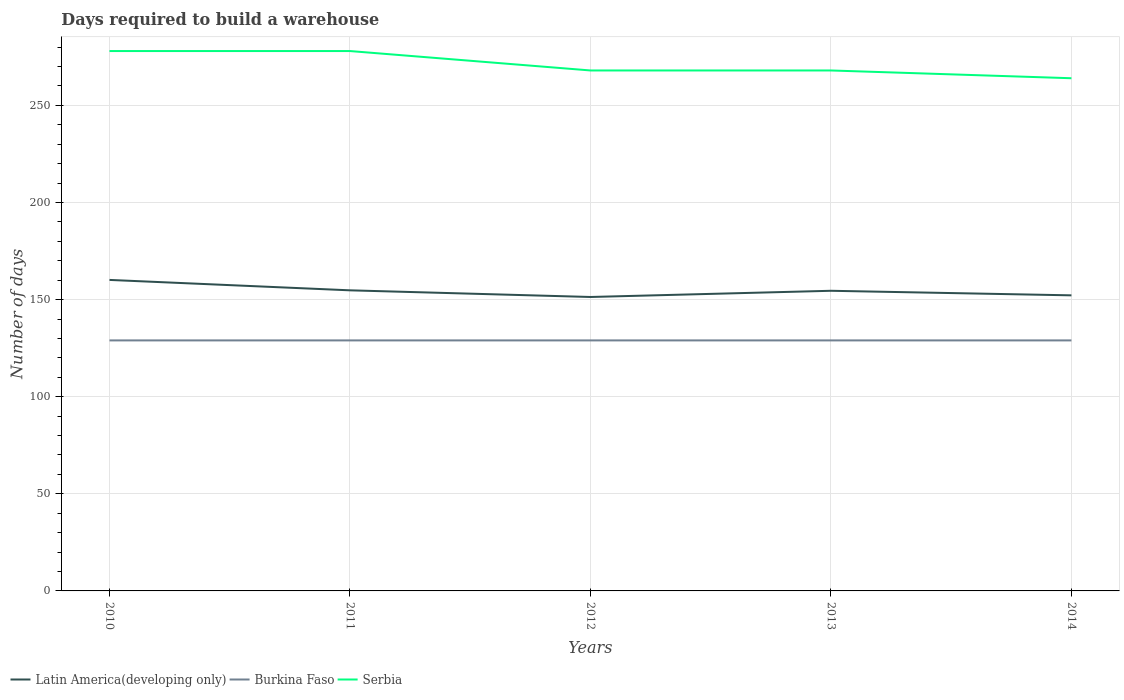How many different coloured lines are there?
Your response must be concise. 3. Does the line corresponding to Burkina Faso intersect with the line corresponding to Serbia?
Make the answer very short. No. Is the number of lines equal to the number of legend labels?
Your answer should be compact. Yes. Across all years, what is the maximum days required to build a warehouse in in Serbia?
Keep it short and to the point. 264. In which year was the days required to build a warehouse in in Serbia maximum?
Your answer should be very brief. 2014. What is the total days required to build a warehouse in in Latin America(developing only) in the graph?
Provide a short and direct response. 3.43. What is the difference between the highest and the second highest days required to build a warehouse in in Latin America(developing only)?
Offer a terse response. 8.79. What is the difference between the highest and the lowest days required to build a warehouse in in Burkina Faso?
Give a very brief answer. 0. Is the days required to build a warehouse in in Latin America(developing only) strictly greater than the days required to build a warehouse in in Serbia over the years?
Keep it short and to the point. Yes. How many years are there in the graph?
Keep it short and to the point. 5. What is the difference between two consecutive major ticks on the Y-axis?
Make the answer very short. 50. Are the values on the major ticks of Y-axis written in scientific E-notation?
Your response must be concise. No. Where does the legend appear in the graph?
Offer a terse response. Bottom left. How are the legend labels stacked?
Provide a short and direct response. Horizontal. What is the title of the graph?
Your answer should be compact. Days required to build a warehouse. Does "Bahrain" appear as one of the legend labels in the graph?
Your response must be concise. No. What is the label or title of the X-axis?
Make the answer very short. Years. What is the label or title of the Y-axis?
Ensure brevity in your answer.  Number of days. What is the Number of days of Latin America(developing only) in 2010?
Your response must be concise. 160.14. What is the Number of days in Burkina Faso in 2010?
Provide a short and direct response. 129. What is the Number of days in Serbia in 2010?
Make the answer very short. 278. What is the Number of days of Latin America(developing only) in 2011?
Provide a short and direct response. 154.79. What is the Number of days of Burkina Faso in 2011?
Give a very brief answer. 129. What is the Number of days of Serbia in 2011?
Keep it short and to the point. 278. What is the Number of days of Latin America(developing only) in 2012?
Your response must be concise. 151.36. What is the Number of days of Burkina Faso in 2012?
Keep it short and to the point. 129. What is the Number of days in Serbia in 2012?
Give a very brief answer. 268. What is the Number of days of Latin America(developing only) in 2013?
Make the answer very short. 154.55. What is the Number of days in Burkina Faso in 2013?
Your answer should be compact. 129. What is the Number of days of Serbia in 2013?
Give a very brief answer. 268. What is the Number of days in Latin America(developing only) in 2014?
Your answer should be very brief. 152.2. What is the Number of days of Burkina Faso in 2014?
Your answer should be compact. 129. What is the Number of days in Serbia in 2014?
Your answer should be very brief. 264. Across all years, what is the maximum Number of days of Latin America(developing only)?
Make the answer very short. 160.14. Across all years, what is the maximum Number of days in Burkina Faso?
Make the answer very short. 129. Across all years, what is the maximum Number of days of Serbia?
Provide a short and direct response. 278. Across all years, what is the minimum Number of days of Latin America(developing only)?
Your answer should be very brief. 151.36. Across all years, what is the minimum Number of days of Burkina Faso?
Your answer should be very brief. 129. Across all years, what is the minimum Number of days in Serbia?
Give a very brief answer. 264. What is the total Number of days of Latin America(developing only) in the graph?
Your answer should be compact. 773.03. What is the total Number of days in Burkina Faso in the graph?
Provide a succinct answer. 645. What is the total Number of days in Serbia in the graph?
Provide a succinct answer. 1356. What is the difference between the Number of days of Latin America(developing only) in 2010 and that in 2011?
Your response must be concise. 5.36. What is the difference between the Number of days of Burkina Faso in 2010 and that in 2011?
Offer a terse response. 0. What is the difference between the Number of days of Serbia in 2010 and that in 2011?
Make the answer very short. 0. What is the difference between the Number of days in Latin America(developing only) in 2010 and that in 2012?
Provide a short and direct response. 8.79. What is the difference between the Number of days in Burkina Faso in 2010 and that in 2012?
Provide a short and direct response. 0. What is the difference between the Number of days of Latin America(developing only) in 2010 and that in 2013?
Provide a succinct answer. 5.59. What is the difference between the Number of days in Serbia in 2010 and that in 2013?
Make the answer very short. 10. What is the difference between the Number of days in Latin America(developing only) in 2010 and that in 2014?
Offer a terse response. 7.94. What is the difference between the Number of days of Latin America(developing only) in 2011 and that in 2012?
Provide a short and direct response. 3.43. What is the difference between the Number of days in Serbia in 2011 and that in 2012?
Your answer should be very brief. 10. What is the difference between the Number of days in Latin America(developing only) in 2011 and that in 2013?
Ensure brevity in your answer.  0.24. What is the difference between the Number of days of Serbia in 2011 and that in 2013?
Your answer should be very brief. 10. What is the difference between the Number of days of Latin America(developing only) in 2011 and that in 2014?
Your answer should be compact. 2.59. What is the difference between the Number of days of Serbia in 2011 and that in 2014?
Make the answer very short. 14. What is the difference between the Number of days in Latin America(developing only) in 2012 and that in 2013?
Provide a short and direct response. -3.19. What is the difference between the Number of days of Latin America(developing only) in 2012 and that in 2014?
Ensure brevity in your answer.  -0.84. What is the difference between the Number of days in Burkina Faso in 2012 and that in 2014?
Provide a succinct answer. 0. What is the difference between the Number of days in Latin America(developing only) in 2013 and that in 2014?
Your answer should be compact. 2.35. What is the difference between the Number of days of Latin America(developing only) in 2010 and the Number of days of Burkina Faso in 2011?
Offer a very short reply. 31.14. What is the difference between the Number of days in Latin America(developing only) in 2010 and the Number of days in Serbia in 2011?
Keep it short and to the point. -117.86. What is the difference between the Number of days of Burkina Faso in 2010 and the Number of days of Serbia in 2011?
Offer a terse response. -149. What is the difference between the Number of days of Latin America(developing only) in 2010 and the Number of days of Burkina Faso in 2012?
Your response must be concise. 31.14. What is the difference between the Number of days in Latin America(developing only) in 2010 and the Number of days in Serbia in 2012?
Make the answer very short. -107.86. What is the difference between the Number of days of Burkina Faso in 2010 and the Number of days of Serbia in 2012?
Your answer should be very brief. -139. What is the difference between the Number of days in Latin America(developing only) in 2010 and the Number of days in Burkina Faso in 2013?
Provide a succinct answer. 31.14. What is the difference between the Number of days of Latin America(developing only) in 2010 and the Number of days of Serbia in 2013?
Your answer should be very brief. -107.86. What is the difference between the Number of days in Burkina Faso in 2010 and the Number of days in Serbia in 2013?
Provide a short and direct response. -139. What is the difference between the Number of days of Latin America(developing only) in 2010 and the Number of days of Burkina Faso in 2014?
Keep it short and to the point. 31.14. What is the difference between the Number of days of Latin America(developing only) in 2010 and the Number of days of Serbia in 2014?
Give a very brief answer. -103.86. What is the difference between the Number of days of Burkina Faso in 2010 and the Number of days of Serbia in 2014?
Make the answer very short. -135. What is the difference between the Number of days in Latin America(developing only) in 2011 and the Number of days in Burkina Faso in 2012?
Make the answer very short. 25.79. What is the difference between the Number of days in Latin America(developing only) in 2011 and the Number of days in Serbia in 2012?
Offer a terse response. -113.21. What is the difference between the Number of days of Burkina Faso in 2011 and the Number of days of Serbia in 2012?
Provide a succinct answer. -139. What is the difference between the Number of days in Latin America(developing only) in 2011 and the Number of days in Burkina Faso in 2013?
Your answer should be very brief. 25.79. What is the difference between the Number of days of Latin America(developing only) in 2011 and the Number of days of Serbia in 2013?
Your response must be concise. -113.21. What is the difference between the Number of days in Burkina Faso in 2011 and the Number of days in Serbia in 2013?
Offer a very short reply. -139. What is the difference between the Number of days in Latin America(developing only) in 2011 and the Number of days in Burkina Faso in 2014?
Your answer should be very brief. 25.79. What is the difference between the Number of days in Latin America(developing only) in 2011 and the Number of days in Serbia in 2014?
Your response must be concise. -109.21. What is the difference between the Number of days in Burkina Faso in 2011 and the Number of days in Serbia in 2014?
Your answer should be compact. -135. What is the difference between the Number of days of Latin America(developing only) in 2012 and the Number of days of Burkina Faso in 2013?
Ensure brevity in your answer.  22.36. What is the difference between the Number of days of Latin America(developing only) in 2012 and the Number of days of Serbia in 2013?
Offer a terse response. -116.64. What is the difference between the Number of days of Burkina Faso in 2012 and the Number of days of Serbia in 2013?
Your answer should be compact. -139. What is the difference between the Number of days in Latin America(developing only) in 2012 and the Number of days in Burkina Faso in 2014?
Provide a succinct answer. 22.36. What is the difference between the Number of days of Latin America(developing only) in 2012 and the Number of days of Serbia in 2014?
Ensure brevity in your answer.  -112.64. What is the difference between the Number of days of Burkina Faso in 2012 and the Number of days of Serbia in 2014?
Make the answer very short. -135. What is the difference between the Number of days of Latin America(developing only) in 2013 and the Number of days of Burkina Faso in 2014?
Provide a succinct answer. 25.55. What is the difference between the Number of days in Latin America(developing only) in 2013 and the Number of days in Serbia in 2014?
Provide a short and direct response. -109.45. What is the difference between the Number of days of Burkina Faso in 2013 and the Number of days of Serbia in 2014?
Your answer should be very brief. -135. What is the average Number of days of Latin America(developing only) per year?
Your response must be concise. 154.61. What is the average Number of days of Burkina Faso per year?
Make the answer very short. 129. What is the average Number of days of Serbia per year?
Make the answer very short. 271.2. In the year 2010, what is the difference between the Number of days of Latin America(developing only) and Number of days of Burkina Faso?
Your answer should be compact. 31.14. In the year 2010, what is the difference between the Number of days in Latin America(developing only) and Number of days in Serbia?
Offer a terse response. -117.86. In the year 2010, what is the difference between the Number of days of Burkina Faso and Number of days of Serbia?
Your answer should be compact. -149. In the year 2011, what is the difference between the Number of days of Latin America(developing only) and Number of days of Burkina Faso?
Offer a very short reply. 25.79. In the year 2011, what is the difference between the Number of days in Latin America(developing only) and Number of days in Serbia?
Keep it short and to the point. -123.21. In the year 2011, what is the difference between the Number of days of Burkina Faso and Number of days of Serbia?
Your answer should be compact. -149. In the year 2012, what is the difference between the Number of days in Latin America(developing only) and Number of days in Burkina Faso?
Provide a succinct answer. 22.36. In the year 2012, what is the difference between the Number of days of Latin America(developing only) and Number of days of Serbia?
Your answer should be compact. -116.64. In the year 2012, what is the difference between the Number of days of Burkina Faso and Number of days of Serbia?
Provide a short and direct response. -139. In the year 2013, what is the difference between the Number of days in Latin America(developing only) and Number of days in Burkina Faso?
Your response must be concise. 25.55. In the year 2013, what is the difference between the Number of days in Latin America(developing only) and Number of days in Serbia?
Provide a succinct answer. -113.45. In the year 2013, what is the difference between the Number of days of Burkina Faso and Number of days of Serbia?
Give a very brief answer. -139. In the year 2014, what is the difference between the Number of days in Latin America(developing only) and Number of days in Burkina Faso?
Your answer should be compact. 23.2. In the year 2014, what is the difference between the Number of days in Latin America(developing only) and Number of days in Serbia?
Offer a very short reply. -111.8. In the year 2014, what is the difference between the Number of days of Burkina Faso and Number of days of Serbia?
Your answer should be very brief. -135. What is the ratio of the Number of days in Latin America(developing only) in 2010 to that in 2011?
Your answer should be compact. 1.03. What is the ratio of the Number of days in Burkina Faso in 2010 to that in 2011?
Your answer should be very brief. 1. What is the ratio of the Number of days of Serbia in 2010 to that in 2011?
Provide a short and direct response. 1. What is the ratio of the Number of days in Latin America(developing only) in 2010 to that in 2012?
Offer a very short reply. 1.06. What is the ratio of the Number of days in Burkina Faso in 2010 to that in 2012?
Provide a succinct answer. 1. What is the ratio of the Number of days of Serbia in 2010 to that in 2012?
Ensure brevity in your answer.  1.04. What is the ratio of the Number of days of Latin America(developing only) in 2010 to that in 2013?
Your response must be concise. 1.04. What is the ratio of the Number of days in Burkina Faso in 2010 to that in 2013?
Give a very brief answer. 1. What is the ratio of the Number of days of Serbia in 2010 to that in 2013?
Offer a terse response. 1.04. What is the ratio of the Number of days in Latin America(developing only) in 2010 to that in 2014?
Offer a terse response. 1.05. What is the ratio of the Number of days in Serbia in 2010 to that in 2014?
Your answer should be compact. 1.05. What is the ratio of the Number of days in Latin America(developing only) in 2011 to that in 2012?
Give a very brief answer. 1.02. What is the ratio of the Number of days of Serbia in 2011 to that in 2012?
Keep it short and to the point. 1.04. What is the ratio of the Number of days of Burkina Faso in 2011 to that in 2013?
Ensure brevity in your answer.  1. What is the ratio of the Number of days in Serbia in 2011 to that in 2013?
Keep it short and to the point. 1.04. What is the ratio of the Number of days of Serbia in 2011 to that in 2014?
Offer a terse response. 1.05. What is the ratio of the Number of days in Latin America(developing only) in 2012 to that in 2013?
Offer a very short reply. 0.98. What is the ratio of the Number of days in Latin America(developing only) in 2012 to that in 2014?
Make the answer very short. 0.99. What is the ratio of the Number of days of Serbia in 2012 to that in 2014?
Your answer should be very brief. 1.02. What is the ratio of the Number of days in Latin America(developing only) in 2013 to that in 2014?
Ensure brevity in your answer.  1.02. What is the ratio of the Number of days in Burkina Faso in 2013 to that in 2014?
Your response must be concise. 1. What is the ratio of the Number of days of Serbia in 2013 to that in 2014?
Offer a very short reply. 1.02. What is the difference between the highest and the second highest Number of days of Latin America(developing only)?
Your answer should be compact. 5.36. What is the difference between the highest and the second highest Number of days of Burkina Faso?
Offer a terse response. 0. What is the difference between the highest and the lowest Number of days of Latin America(developing only)?
Provide a short and direct response. 8.79. What is the difference between the highest and the lowest Number of days of Burkina Faso?
Provide a succinct answer. 0. 